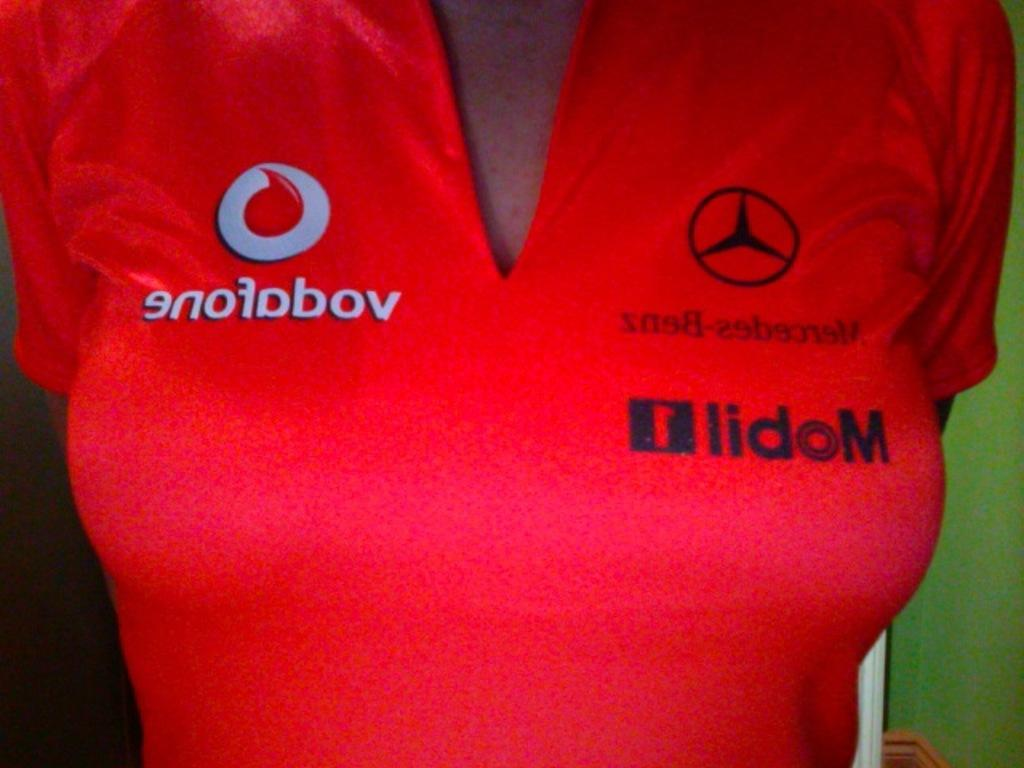<image>
Write a terse but informative summary of the picture. a person with the word lidom on their shirt 